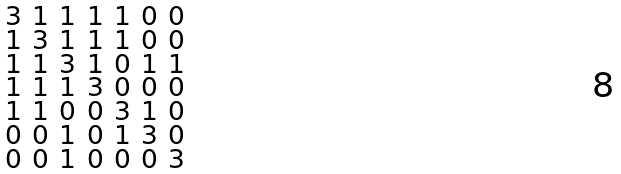Convert formula to latex. <formula><loc_0><loc_0><loc_500><loc_500>\begin{smallmatrix} 3 & 1 & 1 & 1 & 1 & 0 & 0 \\ 1 & 3 & 1 & 1 & 1 & 0 & 0 \\ 1 & 1 & 3 & 1 & 0 & 1 & 1 \\ 1 & 1 & 1 & 3 & 0 & 0 & 0 \\ 1 & 1 & 0 & 0 & 3 & 1 & 0 \\ 0 & 0 & 1 & 0 & 1 & 3 & 0 \\ 0 & 0 & 1 & 0 & 0 & 0 & 3 \end{smallmatrix}</formula> 